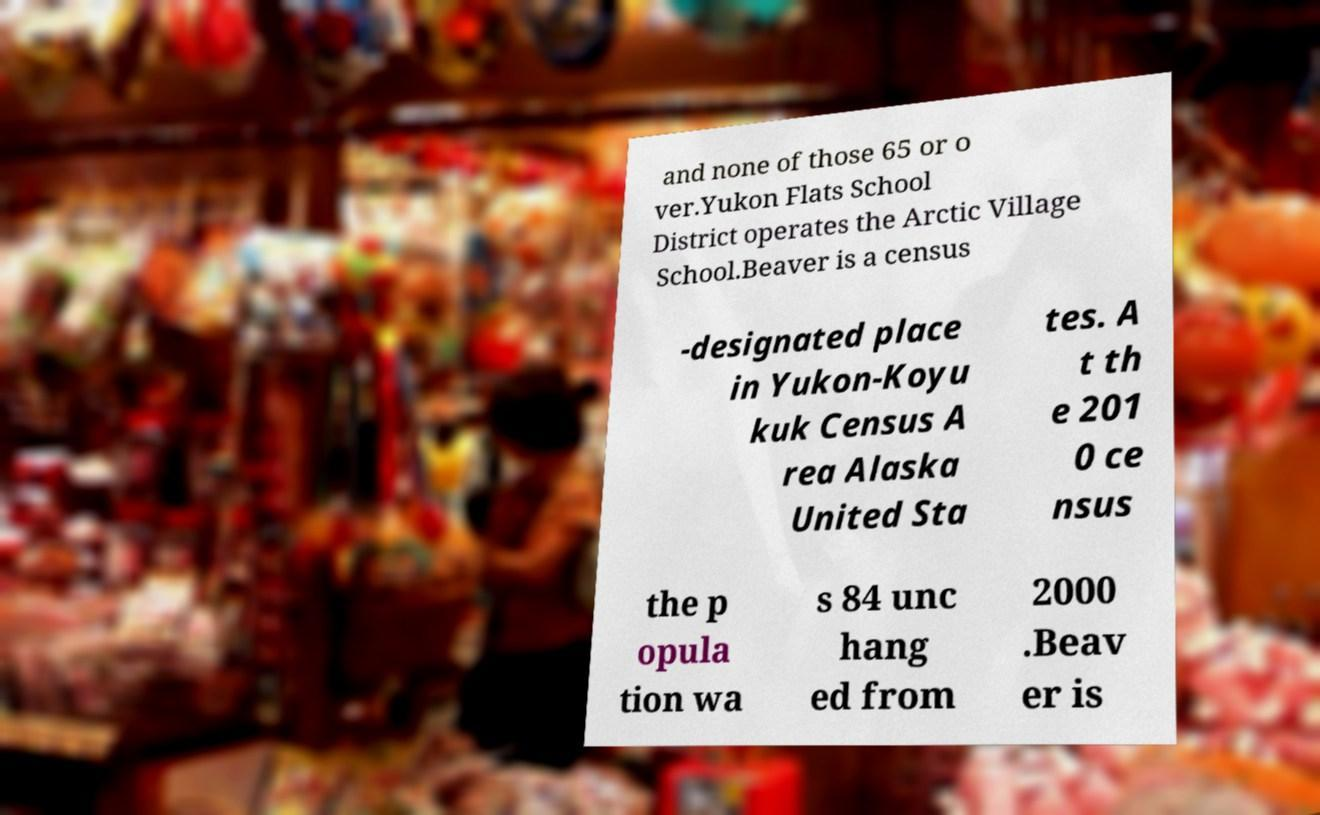I need the written content from this picture converted into text. Can you do that? and none of those 65 or o ver.Yukon Flats School District operates the Arctic Village School.Beaver is a census -designated place in Yukon-Koyu kuk Census A rea Alaska United Sta tes. A t th e 201 0 ce nsus the p opula tion wa s 84 unc hang ed from 2000 .Beav er is 